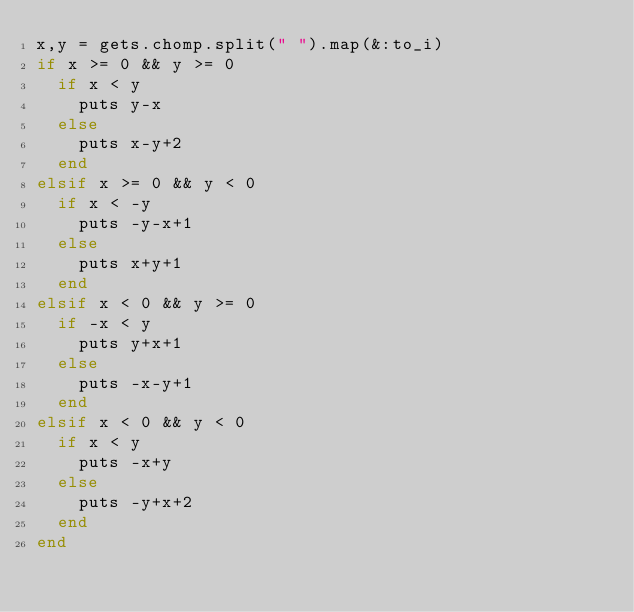<code> <loc_0><loc_0><loc_500><loc_500><_Ruby_>x,y = gets.chomp.split(" ").map(&:to_i)
if x >= 0 && y >= 0
  if x < y
    puts y-x
  else
    puts x-y+2
  end
elsif x >= 0 && y < 0
  if x < -y
    puts -y-x+1
  else
    puts x+y+1
  end
elsif x < 0 && y >= 0
  if -x < y
    puts y+x+1
  else
    puts -x-y+1
  end
elsif x < 0 && y < 0
  if x < y
    puts -x+y
  else
    puts -y+x+2
  end
end</code> 